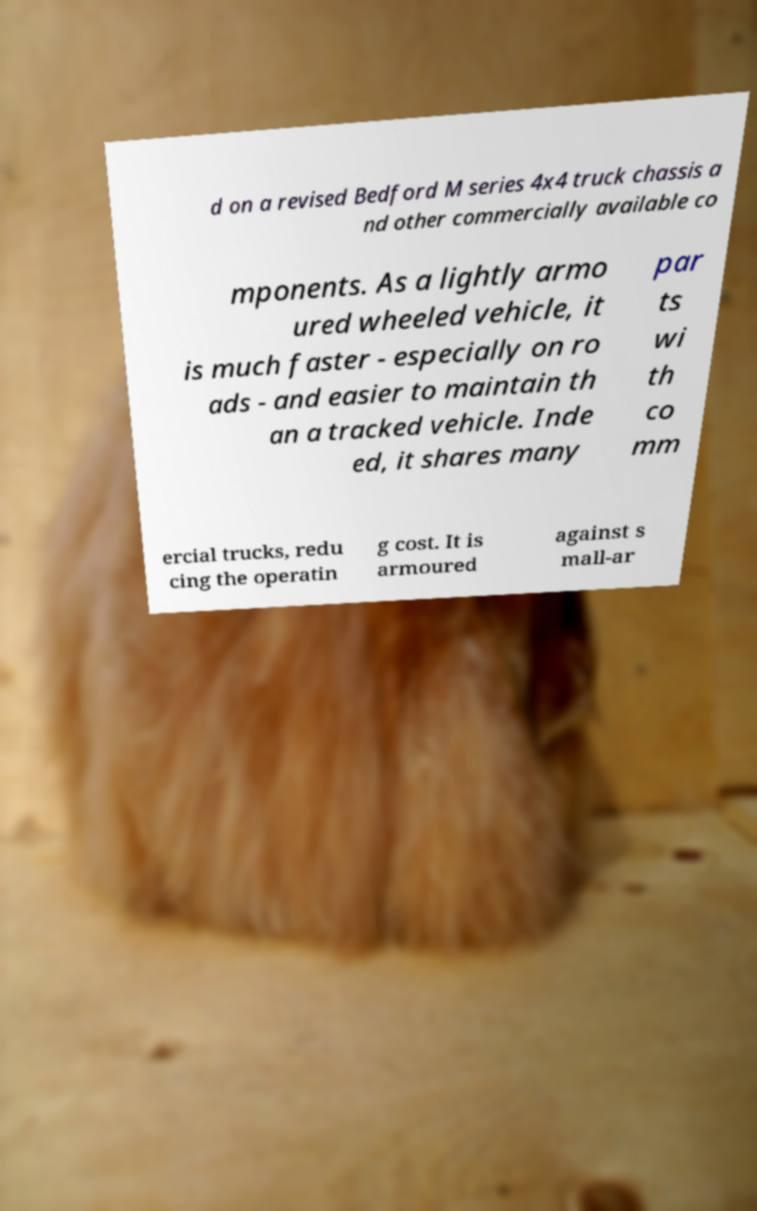Can you read and provide the text displayed in the image?This photo seems to have some interesting text. Can you extract and type it out for me? d on a revised Bedford M series 4x4 truck chassis a nd other commercially available co mponents. As a lightly armo ured wheeled vehicle, it is much faster - especially on ro ads - and easier to maintain th an a tracked vehicle. Inde ed, it shares many par ts wi th co mm ercial trucks, redu cing the operatin g cost. It is armoured against s mall-ar 